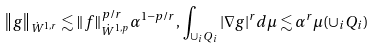Convert formula to latex. <formula><loc_0><loc_0><loc_500><loc_500>\left \| g \right \| _ { \dot { W } ^ { 1 , r } } \lesssim \| f \| _ { \dot { W } ^ { 1 , p } } ^ { p / r } \alpha ^ { 1 - p / r } , \, \int _ { \cup _ { i } { Q _ { i } } } | \nabla g | ^ { r } d \mu \lesssim \alpha ^ { r } \mu ( \cup _ { i } Q _ { i } )</formula> 